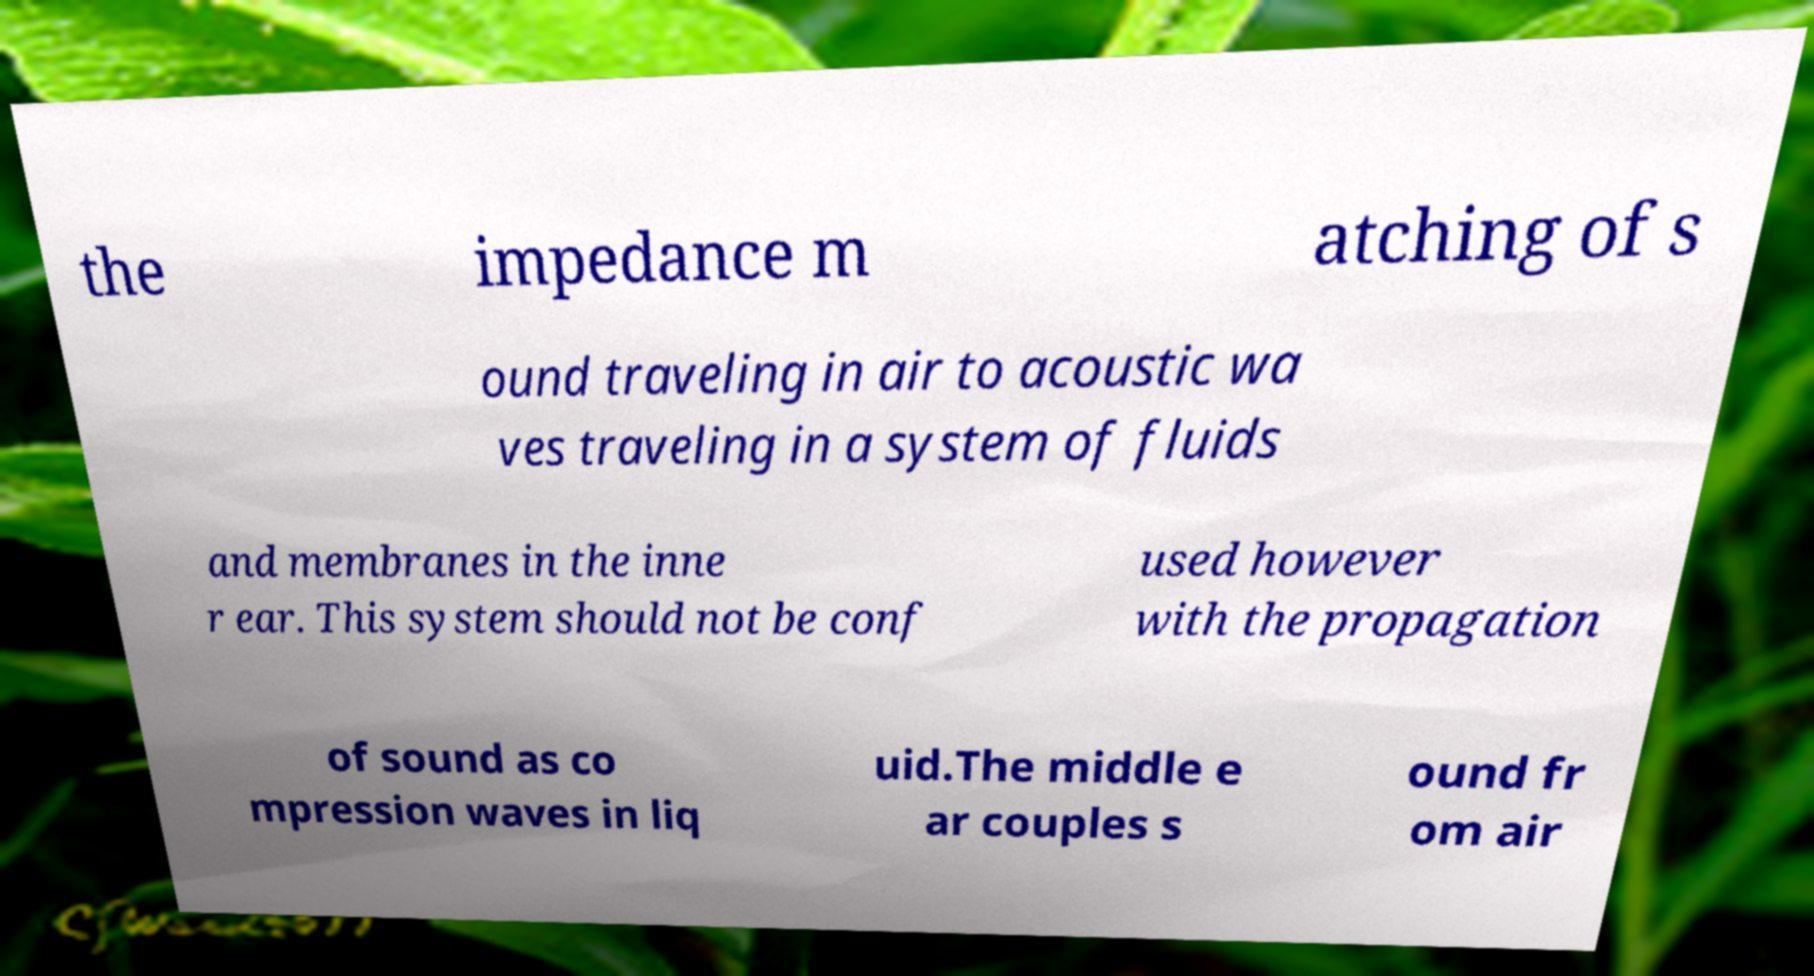Could you extract and type out the text from this image? the impedance m atching of s ound traveling in air to acoustic wa ves traveling in a system of fluids and membranes in the inne r ear. This system should not be conf used however with the propagation of sound as co mpression waves in liq uid.The middle e ar couples s ound fr om air 